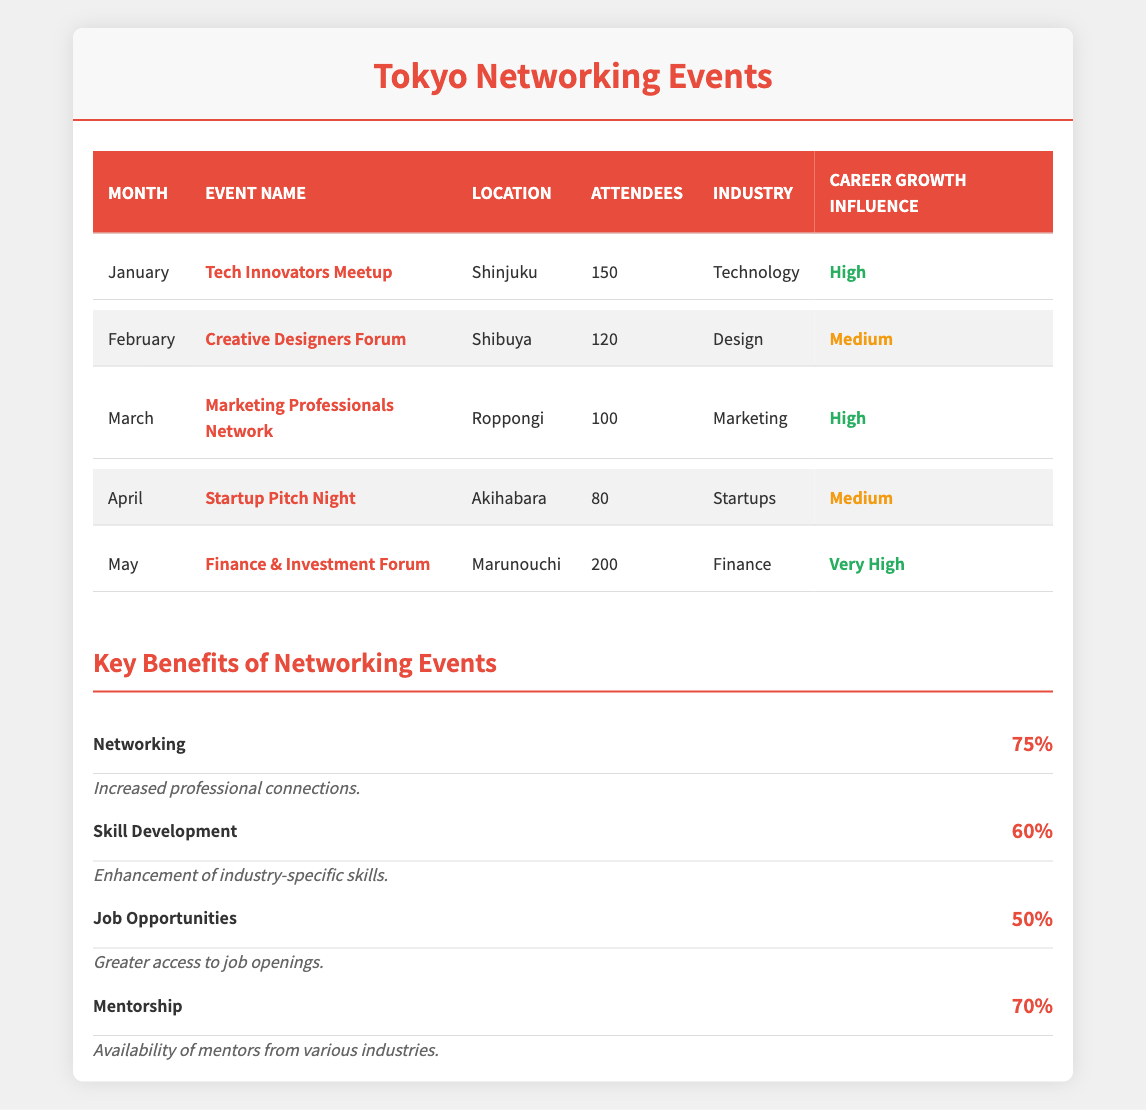What is the location of the Finance & Investment Forum? The table states that the Finance & Investment Forum occurs in Marunouchi.
Answer: Marunouchi How many attendees were present at the Tech Innovators Meetup? According to the table, the Tech Innovators Meetup had 150 attendees.
Answer: 150 Which month had the least number of attendees, and how many were there? The event in April, Startup Pitch Night, had the least number of attendees at 80.
Answer: April, 80 What percentage improvement in networking opportunities is reported for attendees? The table indicates a 75% improvement in networking opportunities from attending the events.
Answer: 75% Which industry had the highest career growth influence based on the events listed? The Finance & Investment Forum from May has a "Very High" influence, which is the highest recorded.
Answer: Finance How many months have events with a "High" career growth influence? The events in January (Tech Innovators Meetup) and March (Marketing Professionals Network) both report "High" influence, totaling two months.
Answer: 2 Is the Creative Designers Forum considered to have a "High" career growth influence? The table classifies the Creative Designers Forum as having a "Medium" influence rather than "High."
Answer: No If you combine the number of attendees from January and February, what is the total? The Tech Innovators Meetup had 150 attendees (January) and the Creative Designers Forum had 120 attendees (February). So, the total is 150 + 120 = 270.
Answer: 270 What is the average number of attendees across the events listed for the first five months? To find the average, sum the attendees: 150 (January) + 120 (February) + 100 (March) + 80 (April) + 200 (May) = 650. Since there are 5 months, the average is 650 / 5 = 130.
Answer: 130 